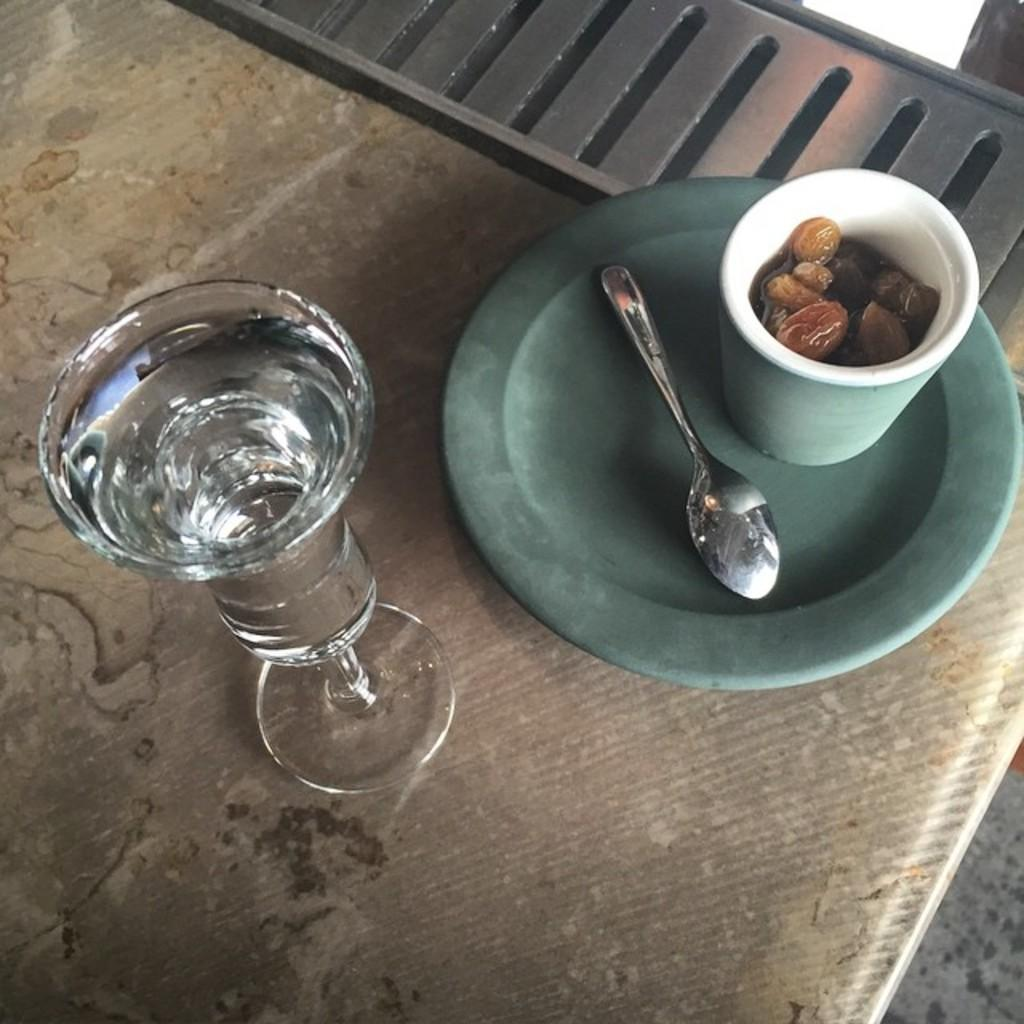What object is visible in the image that is typically used for drinking? There is a glass in the image that is typically used for drinking. What utensil can be seen in the image? There is a spoon in the image. What type of food is present in the glass? Dry fruits are present in the glass. How many cows are visible in the image? There are no cows present in the image. What type of branch is holding the glass in the image? There is no branch holding the glass in the image; the glass is resting on a surface. 